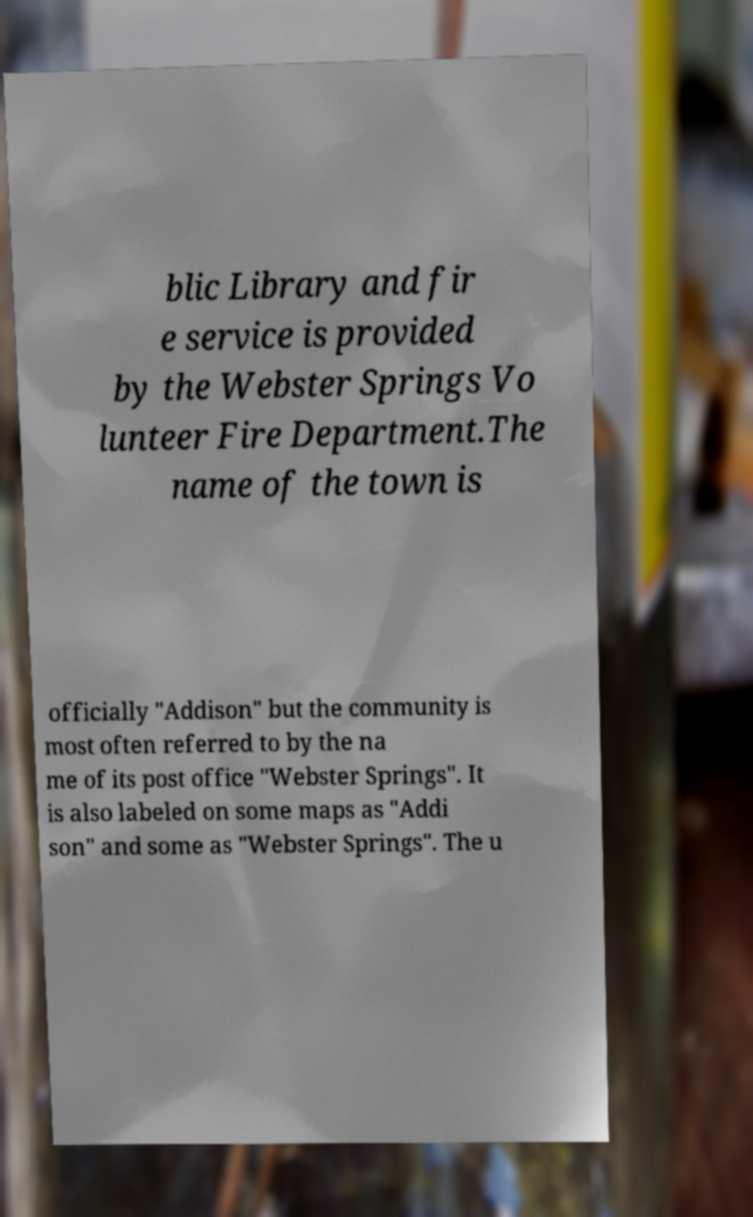Can you read and provide the text displayed in the image?This photo seems to have some interesting text. Can you extract and type it out for me? blic Library and fir e service is provided by the Webster Springs Vo lunteer Fire Department.The name of the town is officially "Addison" but the community is most often referred to by the na me of its post office "Webster Springs". It is also labeled on some maps as "Addi son" and some as "Webster Springs". The u 